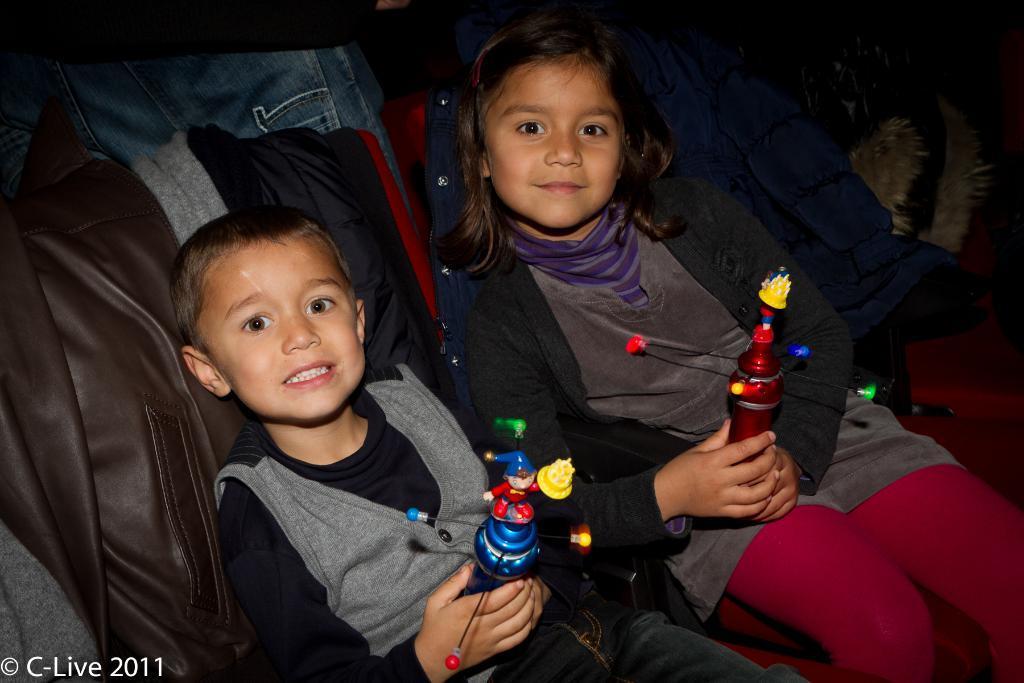How would you summarize this image in a sentence or two? In the foreground of this image, there is a boy and a girl holding toys in their hands and they are sitting on the red chairs on which coats are placed. In the background, there is a person and the dark background. 